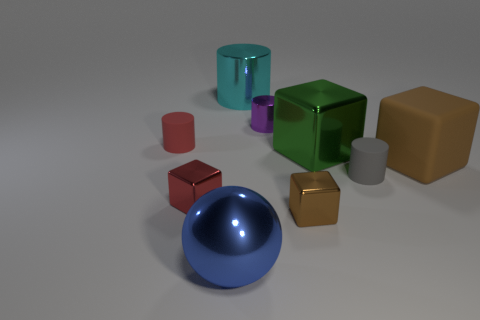Add 1 tiny metal blocks. How many objects exist? 10 Subtract all purple cylinders. How many cylinders are left? 3 Add 8 small cyan cylinders. How many small cyan cylinders exist? 8 Subtract all brown blocks. How many blocks are left? 2 Subtract 2 brown blocks. How many objects are left? 7 Subtract all balls. How many objects are left? 8 Subtract all green cylinders. Subtract all red spheres. How many cylinders are left? 4 Subtract all brown balls. How many green cubes are left? 1 Subtract all small purple objects. Subtract all brown matte cubes. How many objects are left? 7 Add 8 blue metal objects. How many blue metal objects are left? 9 